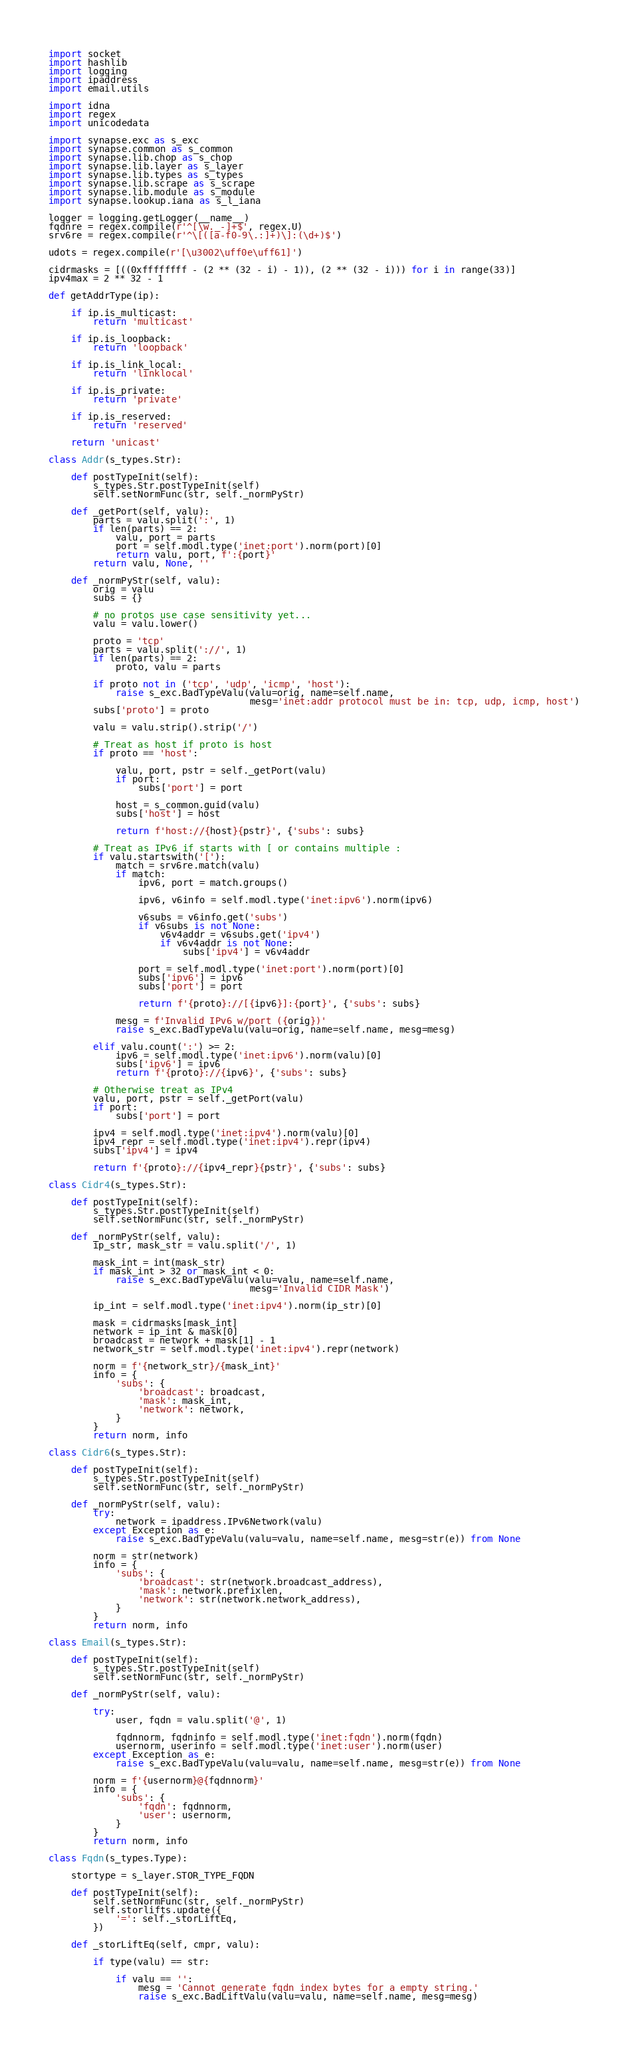<code> <loc_0><loc_0><loc_500><loc_500><_Python_>import socket
import hashlib
import logging
import ipaddress
import email.utils

import idna
import regex
import unicodedata

import synapse.exc as s_exc
import synapse.common as s_common
import synapse.lib.chop as s_chop
import synapse.lib.layer as s_layer
import synapse.lib.types as s_types
import synapse.lib.scrape as s_scrape
import synapse.lib.module as s_module
import synapse.lookup.iana as s_l_iana

logger = logging.getLogger(__name__)
fqdnre = regex.compile(r'^[\w._-]+$', regex.U)
srv6re = regex.compile(r'^\[([a-f0-9\.:]+)\]:(\d+)$')

udots = regex.compile(r'[\u3002\uff0e\uff61]')

cidrmasks = [((0xffffffff - (2 ** (32 - i) - 1)), (2 ** (32 - i))) for i in range(33)]
ipv4max = 2 ** 32 - 1

def getAddrType(ip):

    if ip.is_multicast:
        return 'multicast'

    if ip.is_loopback:
        return 'loopback'

    if ip.is_link_local:
        return 'linklocal'

    if ip.is_private:
        return 'private'

    if ip.is_reserved:
        return 'reserved'

    return 'unicast'

class Addr(s_types.Str):

    def postTypeInit(self):
        s_types.Str.postTypeInit(self)
        self.setNormFunc(str, self._normPyStr)

    def _getPort(self, valu):
        parts = valu.split(':', 1)
        if len(parts) == 2:
            valu, port = parts
            port = self.modl.type('inet:port').norm(port)[0]
            return valu, port, f':{port}'
        return valu, None, ''

    def _normPyStr(self, valu):
        orig = valu
        subs = {}

        # no protos use case sensitivity yet...
        valu = valu.lower()

        proto = 'tcp'
        parts = valu.split('://', 1)
        if len(parts) == 2:
            proto, valu = parts

        if proto not in ('tcp', 'udp', 'icmp', 'host'):
            raise s_exc.BadTypeValu(valu=orig, name=self.name,
                                    mesg='inet:addr protocol must be in: tcp, udp, icmp, host')
        subs['proto'] = proto

        valu = valu.strip().strip('/')

        # Treat as host if proto is host
        if proto == 'host':

            valu, port, pstr = self._getPort(valu)
            if port:
                subs['port'] = port

            host = s_common.guid(valu)
            subs['host'] = host

            return f'host://{host}{pstr}', {'subs': subs}

        # Treat as IPv6 if starts with [ or contains multiple :
        if valu.startswith('['):
            match = srv6re.match(valu)
            if match:
                ipv6, port = match.groups()

                ipv6, v6info = self.modl.type('inet:ipv6').norm(ipv6)

                v6subs = v6info.get('subs')
                if v6subs is not None:
                    v6v4addr = v6subs.get('ipv4')
                    if v6v4addr is not None:
                        subs['ipv4'] = v6v4addr

                port = self.modl.type('inet:port').norm(port)[0]
                subs['ipv6'] = ipv6
                subs['port'] = port

                return f'{proto}://[{ipv6}]:{port}', {'subs': subs}

            mesg = f'Invalid IPv6 w/port ({orig})'
            raise s_exc.BadTypeValu(valu=orig, name=self.name, mesg=mesg)

        elif valu.count(':') >= 2:
            ipv6 = self.modl.type('inet:ipv6').norm(valu)[0]
            subs['ipv6'] = ipv6
            return f'{proto}://{ipv6}', {'subs': subs}

        # Otherwise treat as IPv4
        valu, port, pstr = self._getPort(valu)
        if port:
            subs['port'] = port

        ipv4 = self.modl.type('inet:ipv4').norm(valu)[0]
        ipv4_repr = self.modl.type('inet:ipv4').repr(ipv4)
        subs['ipv4'] = ipv4

        return f'{proto}://{ipv4_repr}{pstr}', {'subs': subs}

class Cidr4(s_types.Str):

    def postTypeInit(self):
        s_types.Str.postTypeInit(self)
        self.setNormFunc(str, self._normPyStr)

    def _normPyStr(self, valu):
        ip_str, mask_str = valu.split('/', 1)

        mask_int = int(mask_str)
        if mask_int > 32 or mask_int < 0:
            raise s_exc.BadTypeValu(valu=valu, name=self.name,
                                    mesg='Invalid CIDR Mask')

        ip_int = self.modl.type('inet:ipv4').norm(ip_str)[0]

        mask = cidrmasks[mask_int]
        network = ip_int & mask[0]
        broadcast = network + mask[1] - 1
        network_str = self.modl.type('inet:ipv4').repr(network)

        norm = f'{network_str}/{mask_int}'
        info = {
            'subs': {
                'broadcast': broadcast,
                'mask': mask_int,
                'network': network,
            }
        }
        return norm, info

class Cidr6(s_types.Str):

    def postTypeInit(self):
        s_types.Str.postTypeInit(self)
        self.setNormFunc(str, self._normPyStr)

    def _normPyStr(self, valu):
        try:
            network = ipaddress.IPv6Network(valu)
        except Exception as e:
            raise s_exc.BadTypeValu(valu=valu, name=self.name, mesg=str(e)) from None

        norm = str(network)
        info = {
            'subs': {
                'broadcast': str(network.broadcast_address),
                'mask': network.prefixlen,
                'network': str(network.network_address),
            }
        }
        return norm, info

class Email(s_types.Str):

    def postTypeInit(self):
        s_types.Str.postTypeInit(self)
        self.setNormFunc(str, self._normPyStr)

    def _normPyStr(self, valu):

        try:
            user, fqdn = valu.split('@', 1)

            fqdnnorm, fqdninfo = self.modl.type('inet:fqdn').norm(fqdn)
            usernorm, userinfo = self.modl.type('inet:user').norm(user)
        except Exception as e:
            raise s_exc.BadTypeValu(valu=valu, name=self.name, mesg=str(e)) from None

        norm = f'{usernorm}@{fqdnnorm}'
        info = {
            'subs': {
                'fqdn': fqdnnorm,
                'user': usernorm,
            }
        }
        return norm, info

class Fqdn(s_types.Type):

    stortype = s_layer.STOR_TYPE_FQDN

    def postTypeInit(self):
        self.setNormFunc(str, self._normPyStr)
        self.storlifts.update({
            '=': self._storLiftEq,
        })

    def _storLiftEq(self, cmpr, valu):

        if type(valu) == str:

            if valu == '':
                mesg = 'Cannot generate fqdn index bytes for a empty string.'
                raise s_exc.BadLiftValu(valu=valu, name=self.name, mesg=mesg)
</code> 